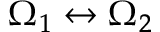Convert formula to latex. <formula><loc_0><loc_0><loc_500><loc_500>\Omega _ { 1 } \leftrightarrow \Omega _ { 2 }</formula> 